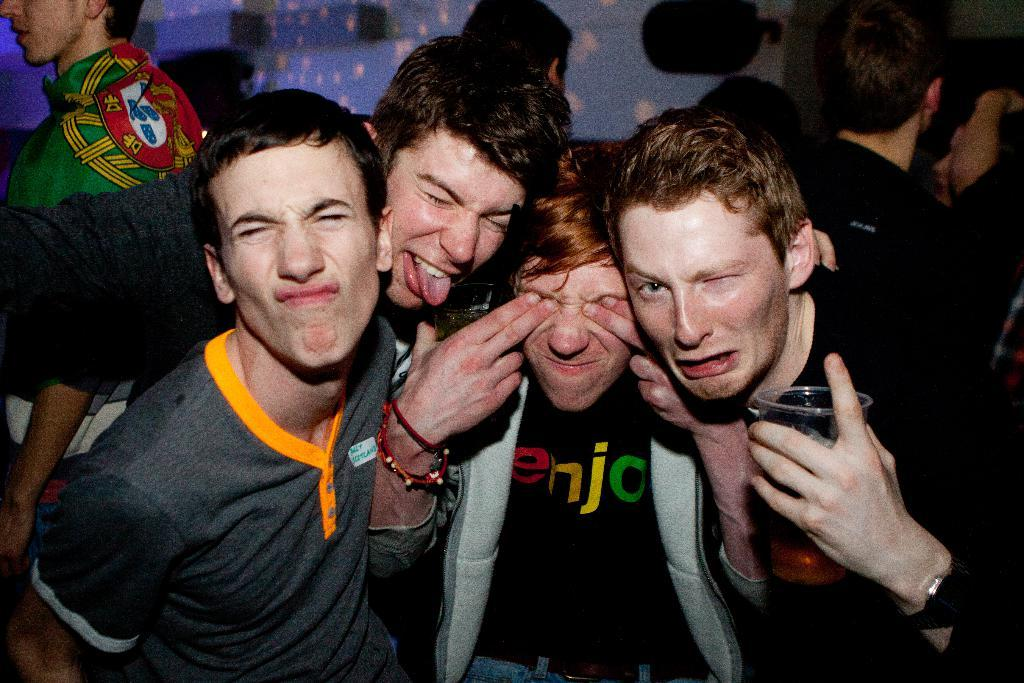How many people are in the image? There is a group of people in the image, but the exact number is not specified. Can you describe what one of the people is doing in the image? One man in the group is holding a glass in his hand. How many horses are present in the image? There are no horses visible in the image. What is the amount of water in the glass being held by the man? The amount of water in the glass is not visible in the image, as only the glass itself is shown. 